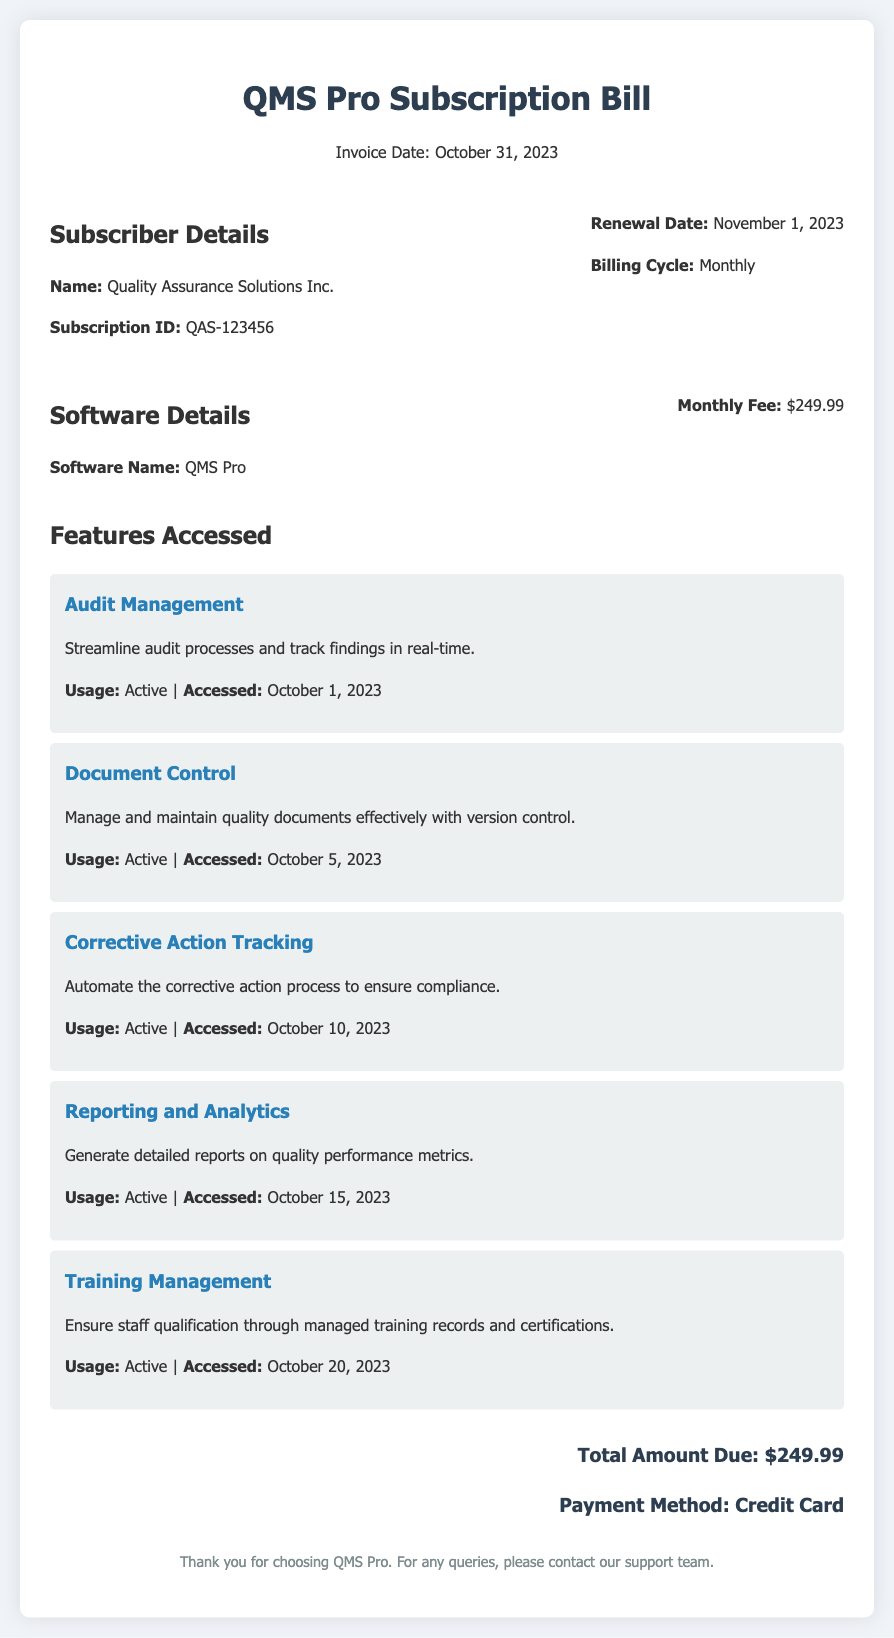What is the name of the subscriber? The document provides the name of the subscriber in the subscriber details section, which is "Quality Assurance Solutions Inc."
Answer: Quality Assurance Solutions Inc What is the subscription ID? The subscription ID is specified in the subscriber details, marked as "Subscription ID".
Answer: QAS-123456 When is the renewal date? The renewal date is stated clearly in the subscriber details section as "November 1, 2023".
Answer: November 1, 2023 How much is the monthly fee? The monthly fee is detailed in the software details section of the document and indicated as "$249.99".
Answer: $249.99 What features were accessed in October? The document lists the features along with their accessed dates, revealing multiple features accessed in October.
Answer: Audit Management, Document Control, Corrective Action Tracking, Reporting and Analytics, Training Management What type of payment method is used? The payment method is indicated at the end of the document under the total amount due section and is listed as "Credit Card".
Answer: Credit Card What is the total amount due? The total amount due is highlighted in the totals area of the document, specifically stated as "$249.99".
Answer: $249.99 How many features are currently accessed? The document lists five different features being accessed actively, providing a count of the active features.
Answer: 5 What is the billing cycle frequency? The billing cycle is described in the subscriber details section as "Monthly".
Answer: Monthly 